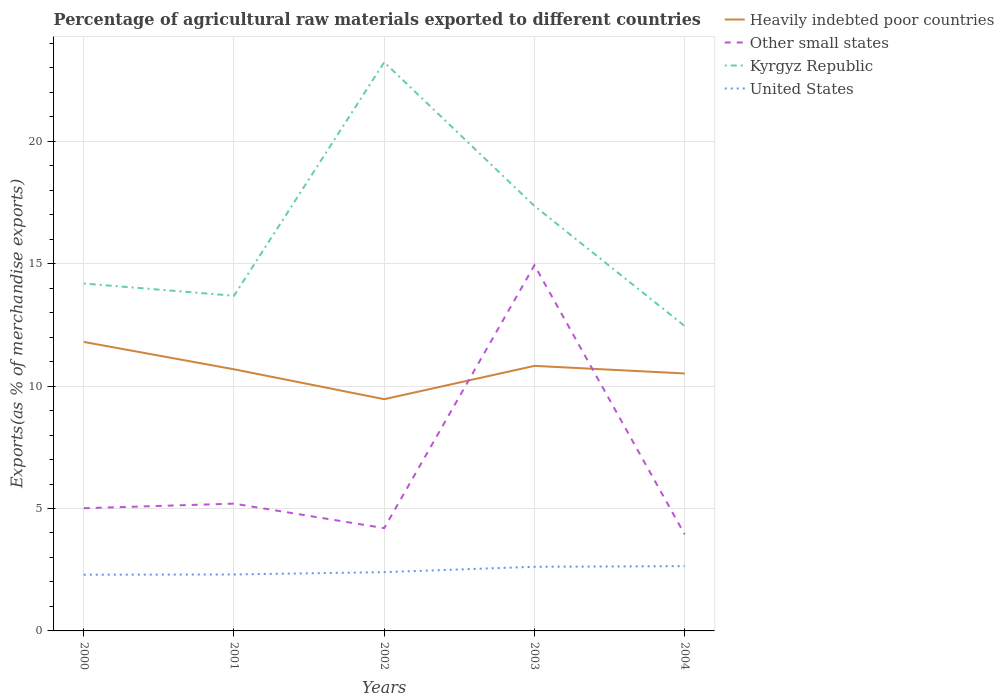How many different coloured lines are there?
Keep it short and to the point. 4. Does the line corresponding to Kyrgyz Republic intersect with the line corresponding to Other small states?
Your answer should be very brief. No. Is the number of lines equal to the number of legend labels?
Ensure brevity in your answer.  Yes. Across all years, what is the maximum percentage of exports to different countries in Heavily indebted poor countries?
Make the answer very short. 9.47. What is the total percentage of exports to different countries in United States in the graph?
Provide a short and direct response. -0.02. What is the difference between the highest and the second highest percentage of exports to different countries in Kyrgyz Republic?
Ensure brevity in your answer.  10.78. Are the values on the major ticks of Y-axis written in scientific E-notation?
Your answer should be compact. No. Does the graph contain grids?
Offer a terse response. Yes. How are the legend labels stacked?
Provide a succinct answer. Vertical. What is the title of the graph?
Your answer should be compact. Percentage of agricultural raw materials exported to different countries. Does "Lower middle income" appear as one of the legend labels in the graph?
Provide a succinct answer. No. What is the label or title of the Y-axis?
Make the answer very short. Exports(as % of merchandise exports). What is the Exports(as % of merchandise exports) of Heavily indebted poor countries in 2000?
Provide a short and direct response. 11.81. What is the Exports(as % of merchandise exports) of Other small states in 2000?
Provide a succinct answer. 5.01. What is the Exports(as % of merchandise exports) in Kyrgyz Republic in 2000?
Ensure brevity in your answer.  14.19. What is the Exports(as % of merchandise exports) in United States in 2000?
Ensure brevity in your answer.  2.3. What is the Exports(as % of merchandise exports) in Heavily indebted poor countries in 2001?
Your response must be concise. 10.69. What is the Exports(as % of merchandise exports) of Other small states in 2001?
Provide a succinct answer. 5.2. What is the Exports(as % of merchandise exports) of Kyrgyz Republic in 2001?
Offer a very short reply. 13.69. What is the Exports(as % of merchandise exports) of United States in 2001?
Your answer should be compact. 2.31. What is the Exports(as % of merchandise exports) in Heavily indebted poor countries in 2002?
Make the answer very short. 9.47. What is the Exports(as % of merchandise exports) of Other small states in 2002?
Offer a terse response. 4.2. What is the Exports(as % of merchandise exports) in Kyrgyz Republic in 2002?
Your answer should be very brief. 23.23. What is the Exports(as % of merchandise exports) in United States in 2002?
Offer a terse response. 2.4. What is the Exports(as % of merchandise exports) in Heavily indebted poor countries in 2003?
Provide a succinct answer. 10.83. What is the Exports(as % of merchandise exports) of Other small states in 2003?
Keep it short and to the point. 14.94. What is the Exports(as % of merchandise exports) in Kyrgyz Republic in 2003?
Give a very brief answer. 17.36. What is the Exports(as % of merchandise exports) in United States in 2003?
Your answer should be very brief. 2.62. What is the Exports(as % of merchandise exports) of Heavily indebted poor countries in 2004?
Keep it short and to the point. 10.52. What is the Exports(as % of merchandise exports) in Other small states in 2004?
Your response must be concise. 3.94. What is the Exports(as % of merchandise exports) of Kyrgyz Republic in 2004?
Give a very brief answer. 12.45. What is the Exports(as % of merchandise exports) of United States in 2004?
Give a very brief answer. 2.65. Across all years, what is the maximum Exports(as % of merchandise exports) in Heavily indebted poor countries?
Give a very brief answer. 11.81. Across all years, what is the maximum Exports(as % of merchandise exports) of Other small states?
Offer a very short reply. 14.94. Across all years, what is the maximum Exports(as % of merchandise exports) of Kyrgyz Republic?
Offer a very short reply. 23.23. Across all years, what is the maximum Exports(as % of merchandise exports) in United States?
Provide a succinct answer. 2.65. Across all years, what is the minimum Exports(as % of merchandise exports) of Heavily indebted poor countries?
Keep it short and to the point. 9.47. Across all years, what is the minimum Exports(as % of merchandise exports) of Other small states?
Make the answer very short. 3.94. Across all years, what is the minimum Exports(as % of merchandise exports) of Kyrgyz Republic?
Offer a terse response. 12.45. Across all years, what is the minimum Exports(as % of merchandise exports) of United States?
Make the answer very short. 2.3. What is the total Exports(as % of merchandise exports) in Heavily indebted poor countries in the graph?
Your response must be concise. 53.3. What is the total Exports(as % of merchandise exports) in Other small states in the graph?
Provide a succinct answer. 33.29. What is the total Exports(as % of merchandise exports) of Kyrgyz Republic in the graph?
Keep it short and to the point. 80.92. What is the total Exports(as % of merchandise exports) of United States in the graph?
Keep it short and to the point. 12.27. What is the difference between the Exports(as % of merchandise exports) in Heavily indebted poor countries in 2000 and that in 2001?
Make the answer very short. 1.12. What is the difference between the Exports(as % of merchandise exports) in Other small states in 2000 and that in 2001?
Your answer should be compact. -0.19. What is the difference between the Exports(as % of merchandise exports) of Kyrgyz Republic in 2000 and that in 2001?
Offer a terse response. 0.5. What is the difference between the Exports(as % of merchandise exports) of United States in 2000 and that in 2001?
Your answer should be compact. -0.01. What is the difference between the Exports(as % of merchandise exports) of Heavily indebted poor countries in 2000 and that in 2002?
Ensure brevity in your answer.  2.34. What is the difference between the Exports(as % of merchandise exports) of Other small states in 2000 and that in 2002?
Provide a short and direct response. 0.81. What is the difference between the Exports(as % of merchandise exports) in Kyrgyz Republic in 2000 and that in 2002?
Offer a terse response. -9.04. What is the difference between the Exports(as % of merchandise exports) of United States in 2000 and that in 2002?
Provide a succinct answer. -0.11. What is the difference between the Exports(as % of merchandise exports) of Heavily indebted poor countries in 2000 and that in 2003?
Offer a terse response. 0.98. What is the difference between the Exports(as % of merchandise exports) in Other small states in 2000 and that in 2003?
Your response must be concise. -9.93. What is the difference between the Exports(as % of merchandise exports) of Kyrgyz Republic in 2000 and that in 2003?
Your answer should be very brief. -3.16. What is the difference between the Exports(as % of merchandise exports) in United States in 2000 and that in 2003?
Offer a terse response. -0.32. What is the difference between the Exports(as % of merchandise exports) of Heavily indebted poor countries in 2000 and that in 2004?
Your response must be concise. 1.29. What is the difference between the Exports(as % of merchandise exports) of Other small states in 2000 and that in 2004?
Provide a succinct answer. 1.07. What is the difference between the Exports(as % of merchandise exports) of Kyrgyz Republic in 2000 and that in 2004?
Keep it short and to the point. 1.74. What is the difference between the Exports(as % of merchandise exports) in United States in 2000 and that in 2004?
Provide a succinct answer. -0.35. What is the difference between the Exports(as % of merchandise exports) in Heavily indebted poor countries in 2001 and that in 2002?
Your answer should be very brief. 1.22. What is the difference between the Exports(as % of merchandise exports) of Kyrgyz Republic in 2001 and that in 2002?
Provide a short and direct response. -9.54. What is the difference between the Exports(as % of merchandise exports) in United States in 2001 and that in 2002?
Your answer should be compact. -0.1. What is the difference between the Exports(as % of merchandise exports) of Heavily indebted poor countries in 2001 and that in 2003?
Your answer should be very brief. -0.14. What is the difference between the Exports(as % of merchandise exports) of Other small states in 2001 and that in 2003?
Make the answer very short. -9.74. What is the difference between the Exports(as % of merchandise exports) of Kyrgyz Republic in 2001 and that in 2003?
Provide a succinct answer. -3.67. What is the difference between the Exports(as % of merchandise exports) in United States in 2001 and that in 2003?
Keep it short and to the point. -0.31. What is the difference between the Exports(as % of merchandise exports) in Heavily indebted poor countries in 2001 and that in 2004?
Ensure brevity in your answer.  0.17. What is the difference between the Exports(as % of merchandise exports) of Other small states in 2001 and that in 2004?
Make the answer very short. 1.26. What is the difference between the Exports(as % of merchandise exports) of Kyrgyz Republic in 2001 and that in 2004?
Provide a short and direct response. 1.24. What is the difference between the Exports(as % of merchandise exports) of United States in 2001 and that in 2004?
Keep it short and to the point. -0.34. What is the difference between the Exports(as % of merchandise exports) of Heavily indebted poor countries in 2002 and that in 2003?
Provide a succinct answer. -1.36. What is the difference between the Exports(as % of merchandise exports) of Other small states in 2002 and that in 2003?
Your response must be concise. -10.74. What is the difference between the Exports(as % of merchandise exports) in Kyrgyz Republic in 2002 and that in 2003?
Offer a very short reply. 5.87. What is the difference between the Exports(as % of merchandise exports) in United States in 2002 and that in 2003?
Provide a short and direct response. -0.22. What is the difference between the Exports(as % of merchandise exports) of Heavily indebted poor countries in 2002 and that in 2004?
Provide a succinct answer. -1.05. What is the difference between the Exports(as % of merchandise exports) in Other small states in 2002 and that in 2004?
Keep it short and to the point. 0.26. What is the difference between the Exports(as % of merchandise exports) of Kyrgyz Republic in 2002 and that in 2004?
Offer a very short reply. 10.78. What is the difference between the Exports(as % of merchandise exports) of United States in 2002 and that in 2004?
Offer a terse response. -0.24. What is the difference between the Exports(as % of merchandise exports) of Heavily indebted poor countries in 2003 and that in 2004?
Provide a succinct answer. 0.31. What is the difference between the Exports(as % of merchandise exports) of Other small states in 2003 and that in 2004?
Keep it short and to the point. 11. What is the difference between the Exports(as % of merchandise exports) in Kyrgyz Republic in 2003 and that in 2004?
Keep it short and to the point. 4.9. What is the difference between the Exports(as % of merchandise exports) of United States in 2003 and that in 2004?
Provide a succinct answer. -0.02. What is the difference between the Exports(as % of merchandise exports) of Heavily indebted poor countries in 2000 and the Exports(as % of merchandise exports) of Other small states in 2001?
Make the answer very short. 6.61. What is the difference between the Exports(as % of merchandise exports) in Heavily indebted poor countries in 2000 and the Exports(as % of merchandise exports) in Kyrgyz Republic in 2001?
Offer a terse response. -1.89. What is the difference between the Exports(as % of merchandise exports) of Heavily indebted poor countries in 2000 and the Exports(as % of merchandise exports) of United States in 2001?
Keep it short and to the point. 9.5. What is the difference between the Exports(as % of merchandise exports) of Other small states in 2000 and the Exports(as % of merchandise exports) of Kyrgyz Republic in 2001?
Provide a succinct answer. -8.68. What is the difference between the Exports(as % of merchandise exports) in Other small states in 2000 and the Exports(as % of merchandise exports) in United States in 2001?
Ensure brevity in your answer.  2.71. What is the difference between the Exports(as % of merchandise exports) of Kyrgyz Republic in 2000 and the Exports(as % of merchandise exports) of United States in 2001?
Provide a succinct answer. 11.89. What is the difference between the Exports(as % of merchandise exports) in Heavily indebted poor countries in 2000 and the Exports(as % of merchandise exports) in Other small states in 2002?
Make the answer very short. 7.61. What is the difference between the Exports(as % of merchandise exports) in Heavily indebted poor countries in 2000 and the Exports(as % of merchandise exports) in Kyrgyz Republic in 2002?
Provide a short and direct response. -11.43. What is the difference between the Exports(as % of merchandise exports) in Heavily indebted poor countries in 2000 and the Exports(as % of merchandise exports) in United States in 2002?
Make the answer very short. 9.4. What is the difference between the Exports(as % of merchandise exports) in Other small states in 2000 and the Exports(as % of merchandise exports) in Kyrgyz Republic in 2002?
Your answer should be compact. -18.22. What is the difference between the Exports(as % of merchandise exports) in Other small states in 2000 and the Exports(as % of merchandise exports) in United States in 2002?
Keep it short and to the point. 2.61. What is the difference between the Exports(as % of merchandise exports) in Kyrgyz Republic in 2000 and the Exports(as % of merchandise exports) in United States in 2002?
Your answer should be compact. 11.79. What is the difference between the Exports(as % of merchandise exports) in Heavily indebted poor countries in 2000 and the Exports(as % of merchandise exports) in Other small states in 2003?
Make the answer very short. -3.13. What is the difference between the Exports(as % of merchandise exports) in Heavily indebted poor countries in 2000 and the Exports(as % of merchandise exports) in Kyrgyz Republic in 2003?
Make the answer very short. -5.55. What is the difference between the Exports(as % of merchandise exports) in Heavily indebted poor countries in 2000 and the Exports(as % of merchandise exports) in United States in 2003?
Your response must be concise. 9.18. What is the difference between the Exports(as % of merchandise exports) in Other small states in 2000 and the Exports(as % of merchandise exports) in Kyrgyz Republic in 2003?
Your answer should be compact. -12.34. What is the difference between the Exports(as % of merchandise exports) of Other small states in 2000 and the Exports(as % of merchandise exports) of United States in 2003?
Your response must be concise. 2.39. What is the difference between the Exports(as % of merchandise exports) of Kyrgyz Republic in 2000 and the Exports(as % of merchandise exports) of United States in 2003?
Your answer should be compact. 11.57. What is the difference between the Exports(as % of merchandise exports) of Heavily indebted poor countries in 2000 and the Exports(as % of merchandise exports) of Other small states in 2004?
Your answer should be very brief. 7.86. What is the difference between the Exports(as % of merchandise exports) in Heavily indebted poor countries in 2000 and the Exports(as % of merchandise exports) in Kyrgyz Republic in 2004?
Ensure brevity in your answer.  -0.65. What is the difference between the Exports(as % of merchandise exports) of Heavily indebted poor countries in 2000 and the Exports(as % of merchandise exports) of United States in 2004?
Keep it short and to the point. 9.16. What is the difference between the Exports(as % of merchandise exports) of Other small states in 2000 and the Exports(as % of merchandise exports) of Kyrgyz Republic in 2004?
Give a very brief answer. -7.44. What is the difference between the Exports(as % of merchandise exports) of Other small states in 2000 and the Exports(as % of merchandise exports) of United States in 2004?
Ensure brevity in your answer.  2.37. What is the difference between the Exports(as % of merchandise exports) of Kyrgyz Republic in 2000 and the Exports(as % of merchandise exports) of United States in 2004?
Offer a very short reply. 11.55. What is the difference between the Exports(as % of merchandise exports) in Heavily indebted poor countries in 2001 and the Exports(as % of merchandise exports) in Other small states in 2002?
Provide a short and direct response. 6.49. What is the difference between the Exports(as % of merchandise exports) in Heavily indebted poor countries in 2001 and the Exports(as % of merchandise exports) in Kyrgyz Republic in 2002?
Keep it short and to the point. -12.54. What is the difference between the Exports(as % of merchandise exports) of Heavily indebted poor countries in 2001 and the Exports(as % of merchandise exports) of United States in 2002?
Provide a succinct answer. 8.29. What is the difference between the Exports(as % of merchandise exports) of Other small states in 2001 and the Exports(as % of merchandise exports) of Kyrgyz Republic in 2002?
Give a very brief answer. -18.03. What is the difference between the Exports(as % of merchandise exports) in Other small states in 2001 and the Exports(as % of merchandise exports) in United States in 2002?
Make the answer very short. 2.8. What is the difference between the Exports(as % of merchandise exports) in Kyrgyz Republic in 2001 and the Exports(as % of merchandise exports) in United States in 2002?
Make the answer very short. 11.29. What is the difference between the Exports(as % of merchandise exports) of Heavily indebted poor countries in 2001 and the Exports(as % of merchandise exports) of Other small states in 2003?
Your response must be concise. -4.25. What is the difference between the Exports(as % of merchandise exports) in Heavily indebted poor countries in 2001 and the Exports(as % of merchandise exports) in Kyrgyz Republic in 2003?
Provide a succinct answer. -6.67. What is the difference between the Exports(as % of merchandise exports) of Heavily indebted poor countries in 2001 and the Exports(as % of merchandise exports) of United States in 2003?
Ensure brevity in your answer.  8.07. What is the difference between the Exports(as % of merchandise exports) in Other small states in 2001 and the Exports(as % of merchandise exports) in Kyrgyz Republic in 2003?
Offer a terse response. -12.16. What is the difference between the Exports(as % of merchandise exports) in Other small states in 2001 and the Exports(as % of merchandise exports) in United States in 2003?
Your response must be concise. 2.58. What is the difference between the Exports(as % of merchandise exports) in Kyrgyz Republic in 2001 and the Exports(as % of merchandise exports) in United States in 2003?
Ensure brevity in your answer.  11.07. What is the difference between the Exports(as % of merchandise exports) of Heavily indebted poor countries in 2001 and the Exports(as % of merchandise exports) of Other small states in 2004?
Make the answer very short. 6.74. What is the difference between the Exports(as % of merchandise exports) in Heavily indebted poor countries in 2001 and the Exports(as % of merchandise exports) in Kyrgyz Republic in 2004?
Ensure brevity in your answer.  -1.77. What is the difference between the Exports(as % of merchandise exports) of Heavily indebted poor countries in 2001 and the Exports(as % of merchandise exports) of United States in 2004?
Your response must be concise. 8.04. What is the difference between the Exports(as % of merchandise exports) in Other small states in 2001 and the Exports(as % of merchandise exports) in Kyrgyz Republic in 2004?
Your answer should be very brief. -7.25. What is the difference between the Exports(as % of merchandise exports) in Other small states in 2001 and the Exports(as % of merchandise exports) in United States in 2004?
Your answer should be compact. 2.55. What is the difference between the Exports(as % of merchandise exports) of Kyrgyz Republic in 2001 and the Exports(as % of merchandise exports) of United States in 2004?
Keep it short and to the point. 11.05. What is the difference between the Exports(as % of merchandise exports) of Heavily indebted poor countries in 2002 and the Exports(as % of merchandise exports) of Other small states in 2003?
Offer a terse response. -5.47. What is the difference between the Exports(as % of merchandise exports) in Heavily indebted poor countries in 2002 and the Exports(as % of merchandise exports) in Kyrgyz Republic in 2003?
Your answer should be compact. -7.89. What is the difference between the Exports(as % of merchandise exports) in Heavily indebted poor countries in 2002 and the Exports(as % of merchandise exports) in United States in 2003?
Provide a short and direct response. 6.85. What is the difference between the Exports(as % of merchandise exports) of Other small states in 2002 and the Exports(as % of merchandise exports) of Kyrgyz Republic in 2003?
Your answer should be compact. -13.16. What is the difference between the Exports(as % of merchandise exports) in Other small states in 2002 and the Exports(as % of merchandise exports) in United States in 2003?
Your answer should be very brief. 1.58. What is the difference between the Exports(as % of merchandise exports) of Kyrgyz Republic in 2002 and the Exports(as % of merchandise exports) of United States in 2003?
Ensure brevity in your answer.  20.61. What is the difference between the Exports(as % of merchandise exports) of Heavily indebted poor countries in 2002 and the Exports(as % of merchandise exports) of Other small states in 2004?
Provide a short and direct response. 5.52. What is the difference between the Exports(as % of merchandise exports) of Heavily indebted poor countries in 2002 and the Exports(as % of merchandise exports) of Kyrgyz Republic in 2004?
Keep it short and to the point. -2.99. What is the difference between the Exports(as % of merchandise exports) of Heavily indebted poor countries in 2002 and the Exports(as % of merchandise exports) of United States in 2004?
Your answer should be compact. 6.82. What is the difference between the Exports(as % of merchandise exports) of Other small states in 2002 and the Exports(as % of merchandise exports) of Kyrgyz Republic in 2004?
Ensure brevity in your answer.  -8.25. What is the difference between the Exports(as % of merchandise exports) of Other small states in 2002 and the Exports(as % of merchandise exports) of United States in 2004?
Offer a very short reply. 1.55. What is the difference between the Exports(as % of merchandise exports) of Kyrgyz Republic in 2002 and the Exports(as % of merchandise exports) of United States in 2004?
Your response must be concise. 20.59. What is the difference between the Exports(as % of merchandise exports) in Heavily indebted poor countries in 2003 and the Exports(as % of merchandise exports) in Other small states in 2004?
Keep it short and to the point. 6.88. What is the difference between the Exports(as % of merchandise exports) in Heavily indebted poor countries in 2003 and the Exports(as % of merchandise exports) in Kyrgyz Republic in 2004?
Your answer should be compact. -1.63. What is the difference between the Exports(as % of merchandise exports) of Heavily indebted poor countries in 2003 and the Exports(as % of merchandise exports) of United States in 2004?
Your answer should be compact. 8.18. What is the difference between the Exports(as % of merchandise exports) in Other small states in 2003 and the Exports(as % of merchandise exports) in Kyrgyz Republic in 2004?
Keep it short and to the point. 2.48. What is the difference between the Exports(as % of merchandise exports) of Other small states in 2003 and the Exports(as % of merchandise exports) of United States in 2004?
Provide a short and direct response. 12.29. What is the difference between the Exports(as % of merchandise exports) in Kyrgyz Republic in 2003 and the Exports(as % of merchandise exports) in United States in 2004?
Ensure brevity in your answer.  14.71. What is the average Exports(as % of merchandise exports) of Heavily indebted poor countries per year?
Offer a very short reply. 10.66. What is the average Exports(as % of merchandise exports) of Other small states per year?
Offer a terse response. 6.66. What is the average Exports(as % of merchandise exports) of Kyrgyz Republic per year?
Give a very brief answer. 16.18. What is the average Exports(as % of merchandise exports) in United States per year?
Your answer should be compact. 2.45. In the year 2000, what is the difference between the Exports(as % of merchandise exports) of Heavily indebted poor countries and Exports(as % of merchandise exports) of Other small states?
Give a very brief answer. 6.79. In the year 2000, what is the difference between the Exports(as % of merchandise exports) of Heavily indebted poor countries and Exports(as % of merchandise exports) of Kyrgyz Republic?
Your answer should be compact. -2.39. In the year 2000, what is the difference between the Exports(as % of merchandise exports) in Heavily indebted poor countries and Exports(as % of merchandise exports) in United States?
Provide a short and direct response. 9.51. In the year 2000, what is the difference between the Exports(as % of merchandise exports) of Other small states and Exports(as % of merchandise exports) of Kyrgyz Republic?
Offer a very short reply. -9.18. In the year 2000, what is the difference between the Exports(as % of merchandise exports) in Other small states and Exports(as % of merchandise exports) in United States?
Give a very brief answer. 2.72. In the year 2000, what is the difference between the Exports(as % of merchandise exports) of Kyrgyz Republic and Exports(as % of merchandise exports) of United States?
Offer a very short reply. 11.9. In the year 2001, what is the difference between the Exports(as % of merchandise exports) of Heavily indebted poor countries and Exports(as % of merchandise exports) of Other small states?
Your answer should be very brief. 5.49. In the year 2001, what is the difference between the Exports(as % of merchandise exports) of Heavily indebted poor countries and Exports(as % of merchandise exports) of Kyrgyz Republic?
Provide a short and direct response. -3. In the year 2001, what is the difference between the Exports(as % of merchandise exports) in Heavily indebted poor countries and Exports(as % of merchandise exports) in United States?
Your answer should be compact. 8.38. In the year 2001, what is the difference between the Exports(as % of merchandise exports) of Other small states and Exports(as % of merchandise exports) of Kyrgyz Republic?
Your response must be concise. -8.49. In the year 2001, what is the difference between the Exports(as % of merchandise exports) in Other small states and Exports(as % of merchandise exports) in United States?
Offer a very short reply. 2.89. In the year 2001, what is the difference between the Exports(as % of merchandise exports) of Kyrgyz Republic and Exports(as % of merchandise exports) of United States?
Your response must be concise. 11.38. In the year 2002, what is the difference between the Exports(as % of merchandise exports) of Heavily indebted poor countries and Exports(as % of merchandise exports) of Other small states?
Provide a succinct answer. 5.27. In the year 2002, what is the difference between the Exports(as % of merchandise exports) of Heavily indebted poor countries and Exports(as % of merchandise exports) of Kyrgyz Republic?
Offer a terse response. -13.76. In the year 2002, what is the difference between the Exports(as % of merchandise exports) of Heavily indebted poor countries and Exports(as % of merchandise exports) of United States?
Your answer should be very brief. 7.06. In the year 2002, what is the difference between the Exports(as % of merchandise exports) in Other small states and Exports(as % of merchandise exports) in Kyrgyz Republic?
Offer a terse response. -19.03. In the year 2002, what is the difference between the Exports(as % of merchandise exports) of Other small states and Exports(as % of merchandise exports) of United States?
Your response must be concise. 1.8. In the year 2002, what is the difference between the Exports(as % of merchandise exports) of Kyrgyz Republic and Exports(as % of merchandise exports) of United States?
Provide a short and direct response. 20.83. In the year 2003, what is the difference between the Exports(as % of merchandise exports) in Heavily indebted poor countries and Exports(as % of merchandise exports) in Other small states?
Your response must be concise. -4.11. In the year 2003, what is the difference between the Exports(as % of merchandise exports) in Heavily indebted poor countries and Exports(as % of merchandise exports) in Kyrgyz Republic?
Offer a very short reply. -6.53. In the year 2003, what is the difference between the Exports(as % of merchandise exports) in Heavily indebted poor countries and Exports(as % of merchandise exports) in United States?
Give a very brief answer. 8.21. In the year 2003, what is the difference between the Exports(as % of merchandise exports) in Other small states and Exports(as % of merchandise exports) in Kyrgyz Republic?
Offer a very short reply. -2.42. In the year 2003, what is the difference between the Exports(as % of merchandise exports) of Other small states and Exports(as % of merchandise exports) of United States?
Your answer should be compact. 12.32. In the year 2003, what is the difference between the Exports(as % of merchandise exports) of Kyrgyz Republic and Exports(as % of merchandise exports) of United States?
Provide a short and direct response. 14.74. In the year 2004, what is the difference between the Exports(as % of merchandise exports) of Heavily indebted poor countries and Exports(as % of merchandise exports) of Other small states?
Ensure brevity in your answer.  6.57. In the year 2004, what is the difference between the Exports(as % of merchandise exports) of Heavily indebted poor countries and Exports(as % of merchandise exports) of Kyrgyz Republic?
Offer a very short reply. -1.94. In the year 2004, what is the difference between the Exports(as % of merchandise exports) in Heavily indebted poor countries and Exports(as % of merchandise exports) in United States?
Your response must be concise. 7.87. In the year 2004, what is the difference between the Exports(as % of merchandise exports) in Other small states and Exports(as % of merchandise exports) in Kyrgyz Republic?
Give a very brief answer. -8.51. In the year 2004, what is the difference between the Exports(as % of merchandise exports) of Other small states and Exports(as % of merchandise exports) of United States?
Make the answer very short. 1.3. In the year 2004, what is the difference between the Exports(as % of merchandise exports) of Kyrgyz Republic and Exports(as % of merchandise exports) of United States?
Make the answer very short. 9.81. What is the ratio of the Exports(as % of merchandise exports) in Heavily indebted poor countries in 2000 to that in 2001?
Give a very brief answer. 1.1. What is the ratio of the Exports(as % of merchandise exports) of Other small states in 2000 to that in 2001?
Provide a succinct answer. 0.96. What is the ratio of the Exports(as % of merchandise exports) in Kyrgyz Republic in 2000 to that in 2001?
Offer a terse response. 1.04. What is the ratio of the Exports(as % of merchandise exports) of United States in 2000 to that in 2001?
Keep it short and to the point. 1. What is the ratio of the Exports(as % of merchandise exports) in Heavily indebted poor countries in 2000 to that in 2002?
Offer a terse response. 1.25. What is the ratio of the Exports(as % of merchandise exports) in Other small states in 2000 to that in 2002?
Your answer should be compact. 1.19. What is the ratio of the Exports(as % of merchandise exports) of Kyrgyz Republic in 2000 to that in 2002?
Make the answer very short. 0.61. What is the ratio of the Exports(as % of merchandise exports) of United States in 2000 to that in 2002?
Keep it short and to the point. 0.96. What is the ratio of the Exports(as % of merchandise exports) in Heavily indebted poor countries in 2000 to that in 2003?
Your response must be concise. 1.09. What is the ratio of the Exports(as % of merchandise exports) of Other small states in 2000 to that in 2003?
Make the answer very short. 0.34. What is the ratio of the Exports(as % of merchandise exports) in Kyrgyz Republic in 2000 to that in 2003?
Offer a terse response. 0.82. What is the ratio of the Exports(as % of merchandise exports) of United States in 2000 to that in 2003?
Ensure brevity in your answer.  0.88. What is the ratio of the Exports(as % of merchandise exports) of Heavily indebted poor countries in 2000 to that in 2004?
Provide a succinct answer. 1.12. What is the ratio of the Exports(as % of merchandise exports) in Other small states in 2000 to that in 2004?
Keep it short and to the point. 1.27. What is the ratio of the Exports(as % of merchandise exports) of Kyrgyz Republic in 2000 to that in 2004?
Offer a very short reply. 1.14. What is the ratio of the Exports(as % of merchandise exports) of United States in 2000 to that in 2004?
Your answer should be compact. 0.87. What is the ratio of the Exports(as % of merchandise exports) of Heavily indebted poor countries in 2001 to that in 2002?
Your answer should be compact. 1.13. What is the ratio of the Exports(as % of merchandise exports) in Other small states in 2001 to that in 2002?
Provide a short and direct response. 1.24. What is the ratio of the Exports(as % of merchandise exports) in Kyrgyz Republic in 2001 to that in 2002?
Offer a very short reply. 0.59. What is the ratio of the Exports(as % of merchandise exports) in United States in 2001 to that in 2002?
Provide a short and direct response. 0.96. What is the ratio of the Exports(as % of merchandise exports) of Heavily indebted poor countries in 2001 to that in 2003?
Your answer should be very brief. 0.99. What is the ratio of the Exports(as % of merchandise exports) of Other small states in 2001 to that in 2003?
Provide a short and direct response. 0.35. What is the ratio of the Exports(as % of merchandise exports) in Kyrgyz Republic in 2001 to that in 2003?
Provide a succinct answer. 0.79. What is the ratio of the Exports(as % of merchandise exports) in United States in 2001 to that in 2003?
Provide a short and direct response. 0.88. What is the ratio of the Exports(as % of merchandise exports) in Heavily indebted poor countries in 2001 to that in 2004?
Ensure brevity in your answer.  1.02. What is the ratio of the Exports(as % of merchandise exports) in Other small states in 2001 to that in 2004?
Ensure brevity in your answer.  1.32. What is the ratio of the Exports(as % of merchandise exports) in Kyrgyz Republic in 2001 to that in 2004?
Keep it short and to the point. 1.1. What is the ratio of the Exports(as % of merchandise exports) in United States in 2001 to that in 2004?
Your answer should be compact. 0.87. What is the ratio of the Exports(as % of merchandise exports) of Heavily indebted poor countries in 2002 to that in 2003?
Give a very brief answer. 0.87. What is the ratio of the Exports(as % of merchandise exports) of Other small states in 2002 to that in 2003?
Give a very brief answer. 0.28. What is the ratio of the Exports(as % of merchandise exports) in Kyrgyz Republic in 2002 to that in 2003?
Provide a succinct answer. 1.34. What is the ratio of the Exports(as % of merchandise exports) in United States in 2002 to that in 2003?
Give a very brief answer. 0.92. What is the ratio of the Exports(as % of merchandise exports) in Heavily indebted poor countries in 2002 to that in 2004?
Your response must be concise. 0.9. What is the ratio of the Exports(as % of merchandise exports) in Other small states in 2002 to that in 2004?
Ensure brevity in your answer.  1.06. What is the ratio of the Exports(as % of merchandise exports) in Kyrgyz Republic in 2002 to that in 2004?
Offer a very short reply. 1.87. What is the ratio of the Exports(as % of merchandise exports) of United States in 2002 to that in 2004?
Ensure brevity in your answer.  0.91. What is the ratio of the Exports(as % of merchandise exports) of Heavily indebted poor countries in 2003 to that in 2004?
Your answer should be compact. 1.03. What is the ratio of the Exports(as % of merchandise exports) in Other small states in 2003 to that in 2004?
Provide a succinct answer. 3.79. What is the ratio of the Exports(as % of merchandise exports) in Kyrgyz Republic in 2003 to that in 2004?
Keep it short and to the point. 1.39. What is the ratio of the Exports(as % of merchandise exports) in United States in 2003 to that in 2004?
Your answer should be compact. 0.99. What is the difference between the highest and the second highest Exports(as % of merchandise exports) of Heavily indebted poor countries?
Provide a short and direct response. 0.98. What is the difference between the highest and the second highest Exports(as % of merchandise exports) in Other small states?
Give a very brief answer. 9.74. What is the difference between the highest and the second highest Exports(as % of merchandise exports) of Kyrgyz Republic?
Keep it short and to the point. 5.87. What is the difference between the highest and the second highest Exports(as % of merchandise exports) of United States?
Ensure brevity in your answer.  0.02. What is the difference between the highest and the lowest Exports(as % of merchandise exports) in Heavily indebted poor countries?
Provide a short and direct response. 2.34. What is the difference between the highest and the lowest Exports(as % of merchandise exports) of Other small states?
Your response must be concise. 11. What is the difference between the highest and the lowest Exports(as % of merchandise exports) of Kyrgyz Republic?
Offer a very short reply. 10.78. What is the difference between the highest and the lowest Exports(as % of merchandise exports) of United States?
Your answer should be very brief. 0.35. 